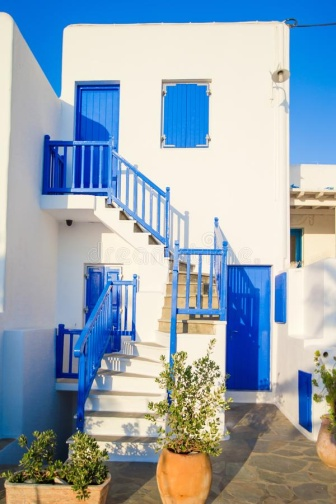Describe the following image.
 The image presents a sunlit, two-story Mediterranean-style building painted in white with blue accents. The building's lower level features a blue door flanked by two windows, also with blue frames and white shutters. A blue staircase on the right side of the building leads up to the second level, which boasts a balcony with a white railing and blue base. 

In front of the building, there are three potted plants, two of which are olive trees, adding a touch of green to the scene. The clear blue sky in the background enhances the overall Mediterranean ambiance. The building, bathed in sunlight, stands out vividly against this backdrop. The image does not contain any discernible text. The relative positions of the objects are consistent with the descriptions provided. 